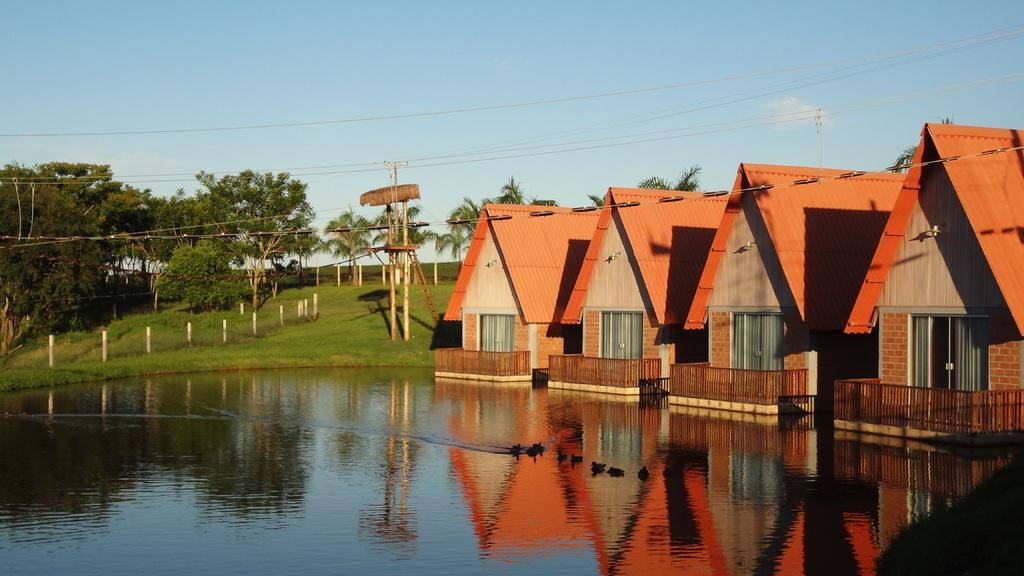What is visible in the image? Water, houses, poles, wires, trees, and the sky are visible in the image. Can you describe the houses in the image? There are houses in the image, but their specific characteristics are not mentioned in the provided facts. What are the poles supporting in the image? The provided facts do not specify what the poles are supporting. What is the condition of the sky in the image? The sky is visible in the background of the image, but its specific condition (e.g., clear, cloudy) is not mentioned in the provided facts. How many sheep can be seen grazing in the water in the image? There are no sheep present in the image. What type of oven is visible in the image? There is no oven present in the image. 